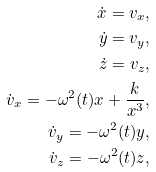Convert formula to latex. <formula><loc_0><loc_0><loc_500><loc_500>\dot { x } = v _ { x } , \\ \dot { y } = v _ { y } , \\ \dot { z } = v _ { z } , \\ \dot { v } _ { x } = - \omega ^ { 2 } ( t ) x + \frac { k } { x ^ { 3 } } , \\ \dot { v } _ { y } = - \omega ^ { 2 } ( t ) y , \\ \dot { v } _ { z } = - \omega ^ { 2 } ( t ) z ,</formula> 